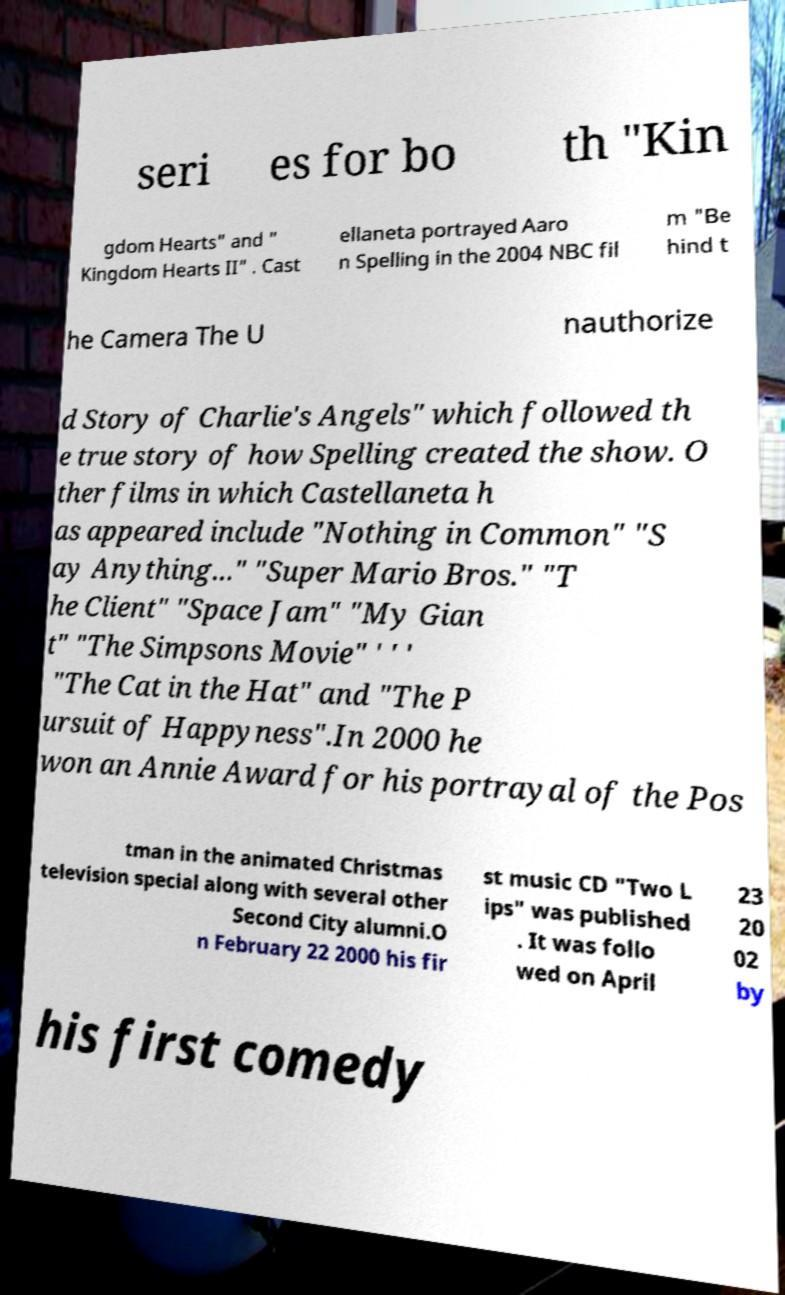For documentation purposes, I need the text within this image transcribed. Could you provide that? seri es for bo th "Kin gdom Hearts" and " Kingdom Hearts II" . Cast ellaneta portrayed Aaro n Spelling in the 2004 NBC fil m "Be hind t he Camera The U nauthorize d Story of Charlie's Angels" which followed th e true story of how Spelling created the show. O ther films in which Castellaneta h as appeared include "Nothing in Common" "S ay Anything..." "Super Mario Bros." "T he Client" "Space Jam" "My Gian t" "The Simpsons Movie" ' ' ' "The Cat in the Hat" and "The P ursuit of Happyness".In 2000 he won an Annie Award for his portrayal of the Pos tman in the animated Christmas television special along with several other Second City alumni.O n February 22 2000 his fir st music CD "Two L ips" was published . It was follo wed on April 23 20 02 by his first comedy 